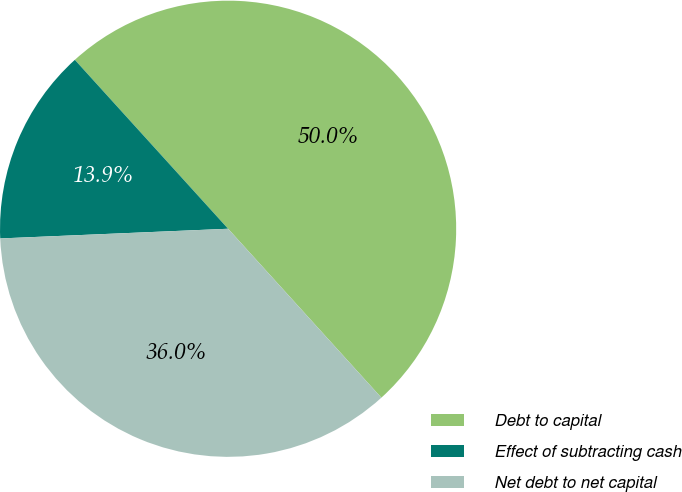Convert chart to OTSL. <chart><loc_0><loc_0><loc_500><loc_500><pie_chart><fcel>Debt to capital<fcel>Effect of subtracting cash<fcel>Net debt to net capital<nl><fcel>50.0%<fcel>13.95%<fcel>36.05%<nl></chart> 